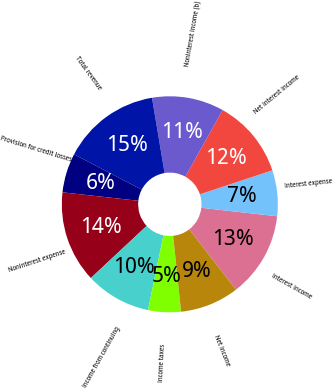<chart> <loc_0><loc_0><loc_500><loc_500><pie_chart><fcel>Interest income<fcel>Interest expense<fcel>Net interest income<fcel>Noninterest income (b)<fcel>Total revenue<fcel>Provision for credit losses<fcel>Noninterest expense<fcel>Income from continuing<fcel>Income taxes<fcel>Net income<nl><fcel>12.74%<fcel>6.86%<fcel>11.76%<fcel>10.78%<fcel>14.7%<fcel>5.88%<fcel>13.72%<fcel>9.8%<fcel>4.9%<fcel>8.82%<nl></chart> 